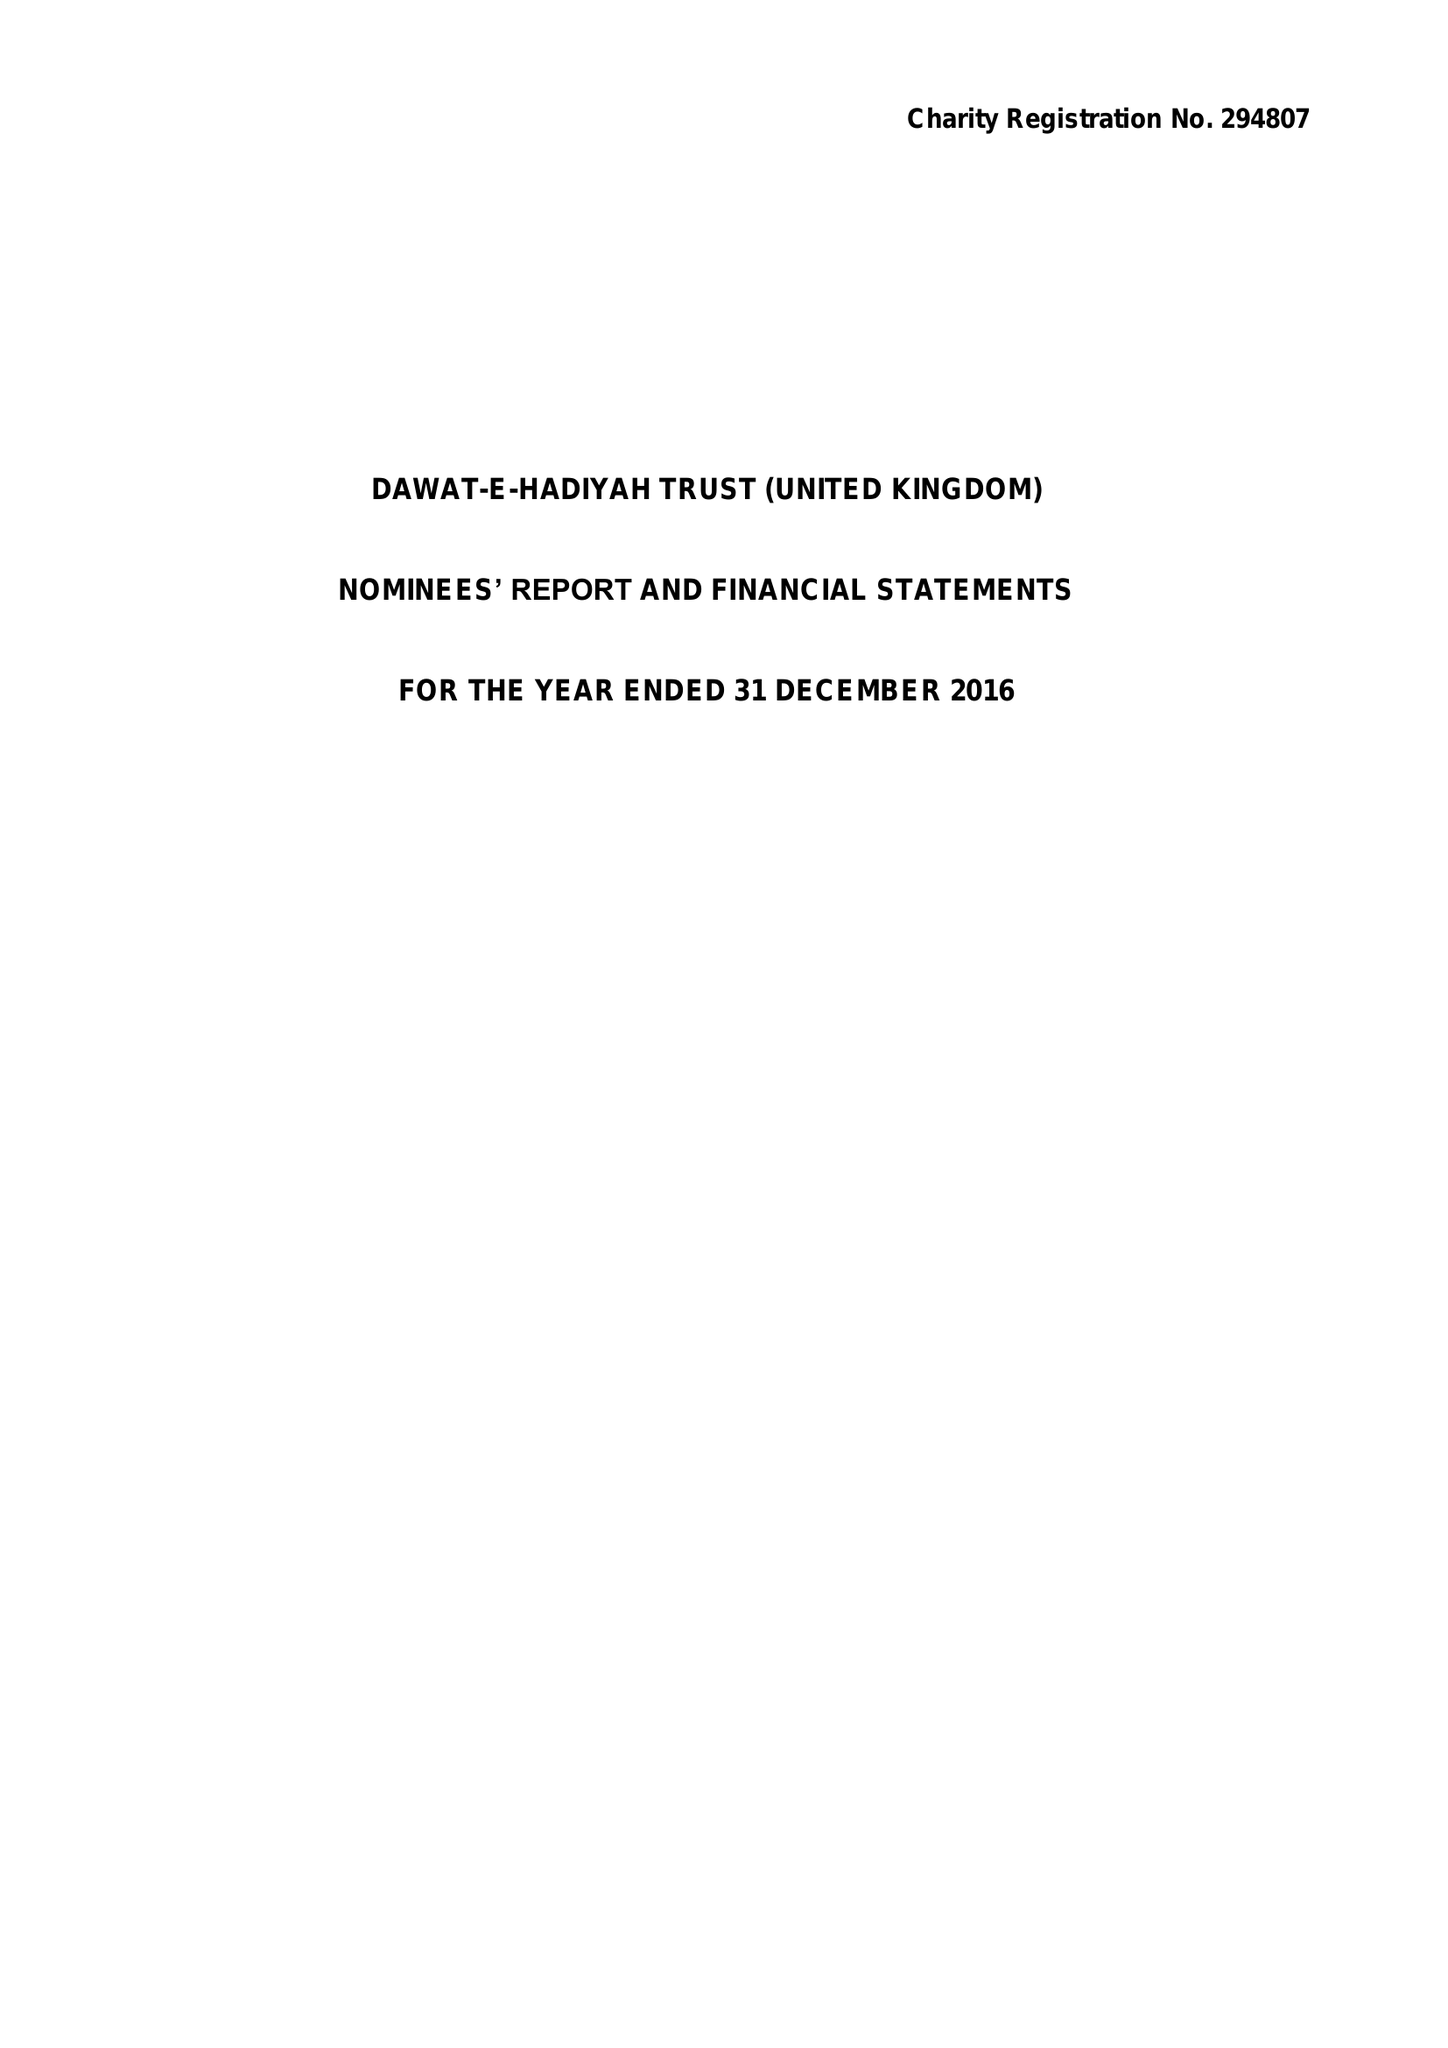What is the value for the spending_annually_in_british_pounds?
Answer the question using a single word or phrase. 4178551.00 